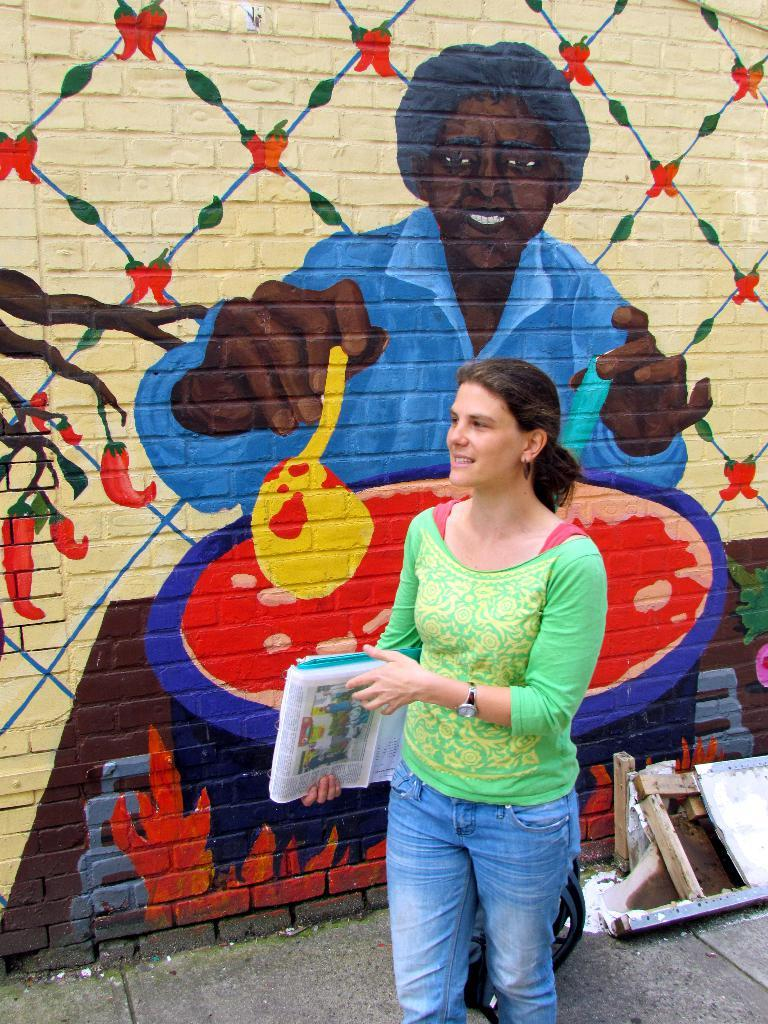Who is present in the image? There is a woman in the image. What is the woman doing in the image? The woman is standing on the ground and smiling. What is the woman holding in her hand? The woman is holding papers in her hand. What can be seen on the wall in the image? There is a wall painting in the image. What is on the ground in the image? There are objects on the ground in the image. What is the weight of the zebra in the image? There is no zebra present in the image, so its weight cannot be determined. 